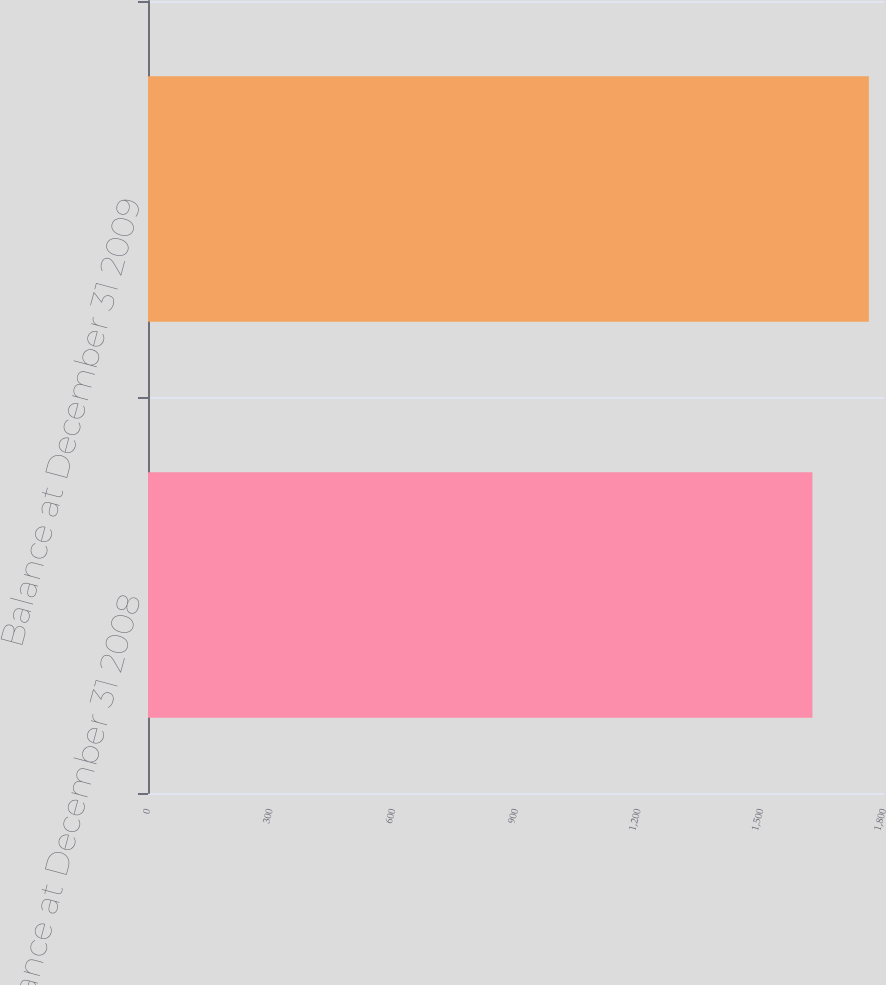Convert chart to OTSL. <chart><loc_0><loc_0><loc_500><loc_500><bar_chart><fcel>Balance at December 31 2008<fcel>Balance at December 31 2009<nl><fcel>1625<fcel>1763<nl></chart> 